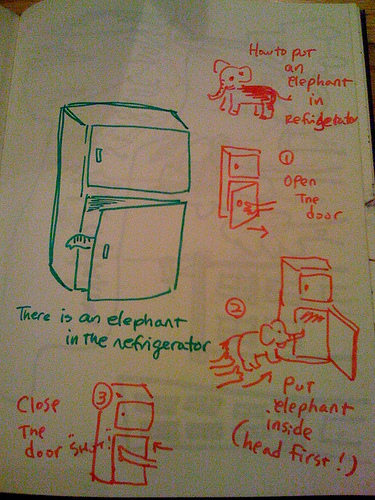Please transcribe the text in this image. There is an elephant in first head inside elephant Put SHUT door The Close 3 refrigerator the 2 door The open 1 Refrigerator in elephant an Put to How 